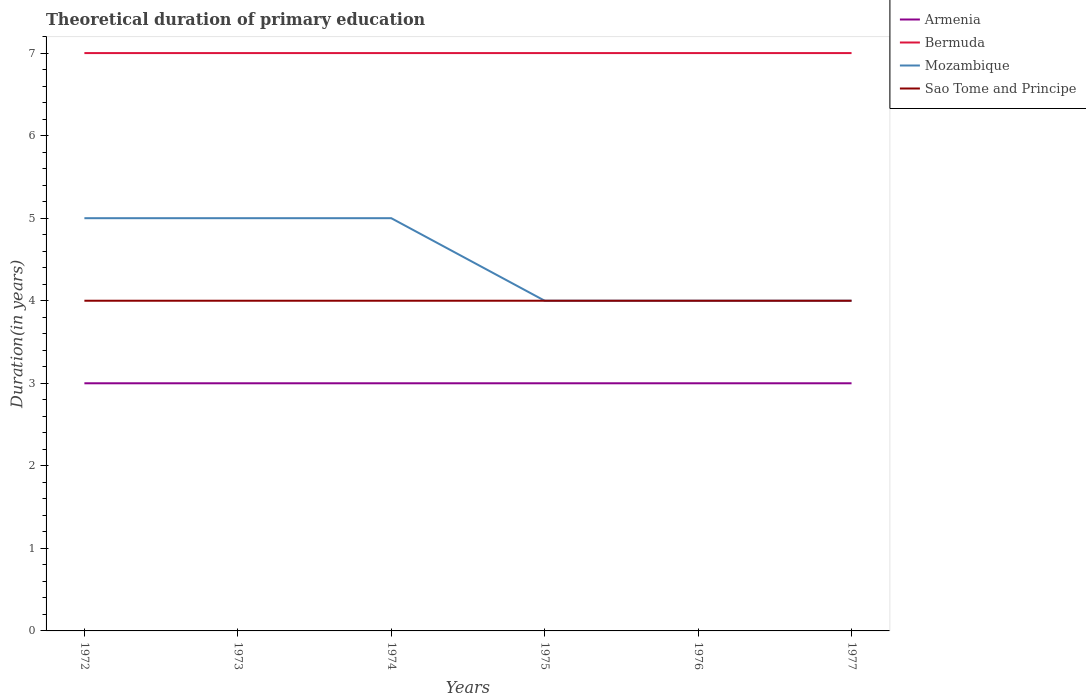Across all years, what is the maximum total theoretical duration of primary education in Sao Tome and Principe?
Your answer should be compact. 4. In which year was the total theoretical duration of primary education in Bermuda maximum?
Your answer should be compact. 1972. What is the difference between the highest and the second highest total theoretical duration of primary education in Bermuda?
Give a very brief answer. 0. What is the difference between the highest and the lowest total theoretical duration of primary education in Armenia?
Offer a terse response. 0. How many lines are there?
Offer a terse response. 4. How many years are there in the graph?
Provide a short and direct response. 6. Are the values on the major ticks of Y-axis written in scientific E-notation?
Ensure brevity in your answer.  No. Does the graph contain grids?
Provide a succinct answer. No. Where does the legend appear in the graph?
Make the answer very short. Top right. What is the title of the graph?
Offer a very short reply. Theoretical duration of primary education. Does "Uzbekistan" appear as one of the legend labels in the graph?
Your answer should be very brief. No. What is the label or title of the X-axis?
Offer a very short reply. Years. What is the label or title of the Y-axis?
Ensure brevity in your answer.  Duration(in years). What is the Duration(in years) in Sao Tome and Principe in 1972?
Your answer should be very brief. 4. What is the Duration(in years) of Mozambique in 1974?
Keep it short and to the point. 5. What is the Duration(in years) in Sao Tome and Principe in 1974?
Your answer should be compact. 4. What is the Duration(in years) of Armenia in 1975?
Give a very brief answer. 3. What is the Duration(in years) in Mozambique in 1975?
Offer a very short reply. 4. What is the Duration(in years) of Sao Tome and Principe in 1975?
Keep it short and to the point. 4. What is the Duration(in years) in Armenia in 1976?
Ensure brevity in your answer.  3. What is the Duration(in years) of Bermuda in 1976?
Offer a terse response. 7. What is the Duration(in years) of Mozambique in 1976?
Make the answer very short. 4. What is the Duration(in years) of Sao Tome and Principe in 1976?
Make the answer very short. 4. What is the Duration(in years) in Bermuda in 1977?
Your answer should be very brief. 7. What is the Duration(in years) in Mozambique in 1977?
Ensure brevity in your answer.  4. What is the Duration(in years) of Sao Tome and Principe in 1977?
Your response must be concise. 4. Across all years, what is the maximum Duration(in years) in Bermuda?
Offer a terse response. 7. Across all years, what is the maximum Duration(in years) of Mozambique?
Provide a succinct answer. 5. Across all years, what is the minimum Duration(in years) in Bermuda?
Provide a short and direct response. 7. What is the total Duration(in years) in Mozambique in the graph?
Provide a succinct answer. 27. What is the total Duration(in years) in Sao Tome and Principe in the graph?
Offer a terse response. 24. What is the difference between the Duration(in years) of Armenia in 1972 and that in 1973?
Your answer should be compact. 0. What is the difference between the Duration(in years) in Bermuda in 1972 and that in 1973?
Make the answer very short. 0. What is the difference between the Duration(in years) of Bermuda in 1972 and that in 1974?
Your answer should be very brief. 0. What is the difference between the Duration(in years) in Mozambique in 1972 and that in 1974?
Give a very brief answer. 0. What is the difference between the Duration(in years) in Sao Tome and Principe in 1972 and that in 1974?
Give a very brief answer. 0. What is the difference between the Duration(in years) of Armenia in 1972 and that in 1976?
Give a very brief answer. 0. What is the difference between the Duration(in years) of Bermuda in 1972 and that in 1976?
Offer a terse response. 0. What is the difference between the Duration(in years) of Sao Tome and Principe in 1972 and that in 1976?
Provide a succinct answer. 0. What is the difference between the Duration(in years) of Bermuda in 1972 and that in 1977?
Provide a succinct answer. 0. What is the difference between the Duration(in years) in Sao Tome and Principe in 1972 and that in 1977?
Keep it short and to the point. 0. What is the difference between the Duration(in years) of Bermuda in 1973 and that in 1974?
Ensure brevity in your answer.  0. What is the difference between the Duration(in years) in Mozambique in 1973 and that in 1974?
Offer a terse response. 0. What is the difference between the Duration(in years) in Sao Tome and Principe in 1973 and that in 1974?
Your response must be concise. 0. What is the difference between the Duration(in years) in Bermuda in 1973 and that in 1976?
Ensure brevity in your answer.  0. What is the difference between the Duration(in years) of Bermuda in 1973 and that in 1977?
Your response must be concise. 0. What is the difference between the Duration(in years) of Sao Tome and Principe in 1973 and that in 1977?
Keep it short and to the point. 0. What is the difference between the Duration(in years) of Armenia in 1974 and that in 1975?
Provide a short and direct response. 0. What is the difference between the Duration(in years) in Bermuda in 1974 and that in 1975?
Make the answer very short. 0. What is the difference between the Duration(in years) of Armenia in 1974 and that in 1976?
Offer a terse response. 0. What is the difference between the Duration(in years) in Bermuda in 1974 and that in 1976?
Make the answer very short. 0. What is the difference between the Duration(in years) of Mozambique in 1974 and that in 1976?
Keep it short and to the point. 1. What is the difference between the Duration(in years) of Bermuda in 1974 and that in 1977?
Ensure brevity in your answer.  0. What is the difference between the Duration(in years) of Sao Tome and Principe in 1974 and that in 1977?
Your answer should be compact. 0. What is the difference between the Duration(in years) of Mozambique in 1975 and that in 1976?
Offer a very short reply. 0. What is the difference between the Duration(in years) in Sao Tome and Principe in 1975 and that in 1976?
Make the answer very short. 0. What is the difference between the Duration(in years) of Mozambique in 1975 and that in 1977?
Offer a terse response. 0. What is the difference between the Duration(in years) of Sao Tome and Principe in 1975 and that in 1977?
Keep it short and to the point. 0. What is the difference between the Duration(in years) of Bermuda in 1976 and that in 1977?
Offer a terse response. 0. What is the difference between the Duration(in years) of Mozambique in 1976 and that in 1977?
Your answer should be compact. 0. What is the difference between the Duration(in years) of Sao Tome and Principe in 1976 and that in 1977?
Your response must be concise. 0. What is the difference between the Duration(in years) in Armenia in 1972 and the Duration(in years) in Bermuda in 1973?
Keep it short and to the point. -4. What is the difference between the Duration(in years) in Armenia in 1972 and the Duration(in years) in Mozambique in 1973?
Your answer should be compact. -2. What is the difference between the Duration(in years) of Bermuda in 1972 and the Duration(in years) of Sao Tome and Principe in 1973?
Make the answer very short. 3. What is the difference between the Duration(in years) of Armenia in 1972 and the Duration(in years) of Mozambique in 1974?
Provide a succinct answer. -2. What is the difference between the Duration(in years) of Armenia in 1972 and the Duration(in years) of Bermuda in 1975?
Your answer should be very brief. -4. What is the difference between the Duration(in years) of Bermuda in 1972 and the Duration(in years) of Sao Tome and Principe in 1975?
Your answer should be compact. 3. What is the difference between the Duration(in years) in Mozambique in 1972 and the Duration(in years) in Sao Tome and Principe in 1975?
Your answer should be compact. 1. What is the difference between the Duration(in years) in Armenia in 1972 and the Duration(in years) in Mozambique in 1976?
Give a very brief answer. -1. What is the difference between the Duration(in years) of Bermuda in 1972 and the Duration(in years) of Mozambique in 1976?
Your answer should be compact. 3. What is the difference between the Duration(in years) in Armenia in 1972 and the Duration(in years) in Bermuda in 1977?
Offer a terse response. -4. What is the difference between the Duration(in years) of Armenia in 1972 and the Duration(in years) of Sao Tome and Principe in 1977?
Make the answer very short. -1. What is the difference between the Duration(in years) of Bermuda in 1972 and the Duration(in years) of Sao Tome and Principe in 1977?
Keep it short and to the point. 3. What is the difference between the Duration(in years) in Bermuda in 1973 and the Duration(in years) in Mozambique in 1974?
Keep it short and to the point. 2. What is the difference between the Duration(in years) of Bermuda in 1973 and the Duration(in years) of Sao Tome and Principe in 1974?
Your response must be concise. 3. What is the difference between the Duration(in years) of Mozambique in 1973 and the Duration(in years) of Sao Tome and Principe in 1974?
Your answer should be very brief. 1. What is the difference between the Duration(in years) in Armenia in 1973 and the Duration(in years) in Mozambique in 1975?
Your response must be concise. -1. What is the difference between the Duration(in years) in Mozambique in 1973 and the Duration(in years) in Sao Tome and Principe in 1975?
Keep it short and to the point. 1. What is the difference between the Duration(in years) in Armenia in 1973 and the Duration(in years) in Bermuda in 1976?
Your answer should be very brief. -4. What is the difference between the Duration(in years) of Armenia in 1973 and the Duration(in years) of Sao Tome and Principe in 1976?
Give a very brief answer. -1. What is the difference between the Duration(in years) of Mozambique in 1973 and the Duration(in years) of Sao Tome and Principe in 1976?
Give a very brief answer. 1. What is the difference between the Duration(in years) of Armenia in 1973 and the Duration(in years) of Sao Tome and Principe in 1977?
Keep it short and to the point. -1. What is the difference between the Duration(in years) of Armenia in 1974 and the Duration(in years) of Bermuda in 1975?
Your answer should be compact. -4. What is the difference between the Duration(in years) of Armenia in 1974 and the Duration(in years) of Sao Tome and Principe in 1975?
Your answer should be very brief. -1. What is the difference between the Duration(in years) of Bermuda in 1974 and the Duration(in years) of Mozambique in 1975?
Offer a very short reply. 3. What is the difference between the Duration(in years) of Bermuda in 1974 and the Duration(in years) of Sao Tome and Principe in 1975?
Provide a succinct answer. 3. What is the difference between the Duration(in years) in Mozambique in 1974 and the Duration(in years) in Sao Tome and Principe in 1975?
Give a very brief answer. 1. What is the difference between the Duration(in years) of Armenia in 1974 and the Duration(in years) of Mozambique in 1976?
Your answer should be very brief. -1. What is the difference between the Duration(in years) in Armenia in 1974 and the Duration(in years) in Sao Tome and Principe in 1976?
Provide a short and direct response. -1. What is the difference between the Duration(in years) of Mozambique in 1974 and the Duration(in years) of Sao Tome and Principe in 1977?
Provide a short and direct response. 1. What is the difference between the Duration(in years) in Bermuda in 1975 and the Duration(in years) in Mozambique in 1976?
Ensure brevity in your answer.  3. What is the difference between the Duration(in years) in Armenia in 1975 and the Duration(in years) in Bermuda in 1977?
Ensure brevity in your answer.  -4. What is the difference between the Duration(in years) in Armenia in 1975 and the Duration(in years) in Mozambique in 1977?
Your answer should be compact. -1. What is the difference between the Duration(in years) in Armenia in 1975 and the Duration(in years) in Sao Tome and Principe in 1977?
Provide a short and direct response. -1. What is the difference between the Duration(in years) of Bermuda in 1975 and the Duration(in years) of Mozambique in 1977?
Ensure brevity in your answer.  3. What is the difference between the Duration(in years) of Bermuda in 1975 and the Duration(in years) of Sao Tome and Principe in 1977?
Ensure brevity in your answer.  3. What is the difference between the Duration(in years) of Mozambique in 1975 and the Duration(in years) of Sao Tome and Principe in 1977?
Your answer should be very brief. 0. What is the difference between the Duration(in years) of Armenia in 1976 and the Duration(in years) of Mozambique in 1977?
Provide a succinct answer. -1. What is the difference between the Duration(in years) in Bermuda in 1976 and the Duration(in years) in Sao Tome and Principe in 1977?
Provide a succinct answer. 3. What is the difference between the Duration(in years) in Mozambique in 1976 and the Duration(in years) in Sao Tome and Principe in 1977?
Keep it short and to the point. 0. What is the average Duration(in years) of Armenia per year?
Give a very brief answer. 3. What is the average Duration(in years) in Bermuda per year?
Make the answer very short. 7. In the year 1972, what is the difference between the Duration(in years) of Bermuda and Duration(in years) of Mozambique?
Your answer should be compact. 2. In the year 1972, what is the difference between the Duration(in years) in Bermuda and Duration(in years) in Sao Tome and Principe?
Offer a very short reply. 3. In the year 1973, what is the difference between the Duration(in years) in Armenia and Duration(in years) in Bermuda?
Provide a succinct answer. -4. In the year 1973, what is the difference between the Duration(in years) of Armenia and Duration(in years) of Mozambique?
Your answer should be very brief. -2. In the year 1973, what is the difference between the Duration(in years) of Armenia and Duration(in years) of Sao Tome and Principe?
Your answer should be very brief. -1. In the year 1973, what is the difference between the Duration(in years) in Bermuda and Duration(in years) in Mozambique?
Keep it short and to the point. 2. In the year 1973, what is the difference between the Duration(in years) in Mozambique and Duration(in years) in Sao Tome and Principe?
Provide a short and direct response. 1. In the year 1974, what is the difference between the Duration(in years) in Armenia and Duration(in years) in Bermuda?
Offer a terse response. -4. In the year 1974, what is the difference between the Duration(in years) in Armenia and Duration(in years) in Mozambique?
Your answer should be very brief. -2. In the year 1974, what is the difference between the Duration(in years) of Bermuda and Duration(in years) of Mozambique?
Your response must be concise. 2. In the year 1975, what is the difference between the Duration(in years) of Armenia and Duration(in years) of Bermuda?
Make the answer very short. -4. In the year 1975, what is the difference between the Duration(in years) of Armenia and Duration(in years) of Mozambique?
Ensure brevity in your answer.  -1. In the year 1975, what is the difference between the Duration(in years) in Bermuda and Duration(in years) in Mozambique?
Offer a terse response. 3. In the year 1975, what is the difference between the Duration(in years) of Bermuda and Duration(in years) of Sao Tome and Principe?
Make the answer very short. 3. In the year 1976, what is the difference between the Duration(in years) in Armenia and Duration(in years) in Mozambique?
Your answer should be compact. -1. In the year 1976, what is the difference between the Duration(in years) in Bermuda and Duration(in years) in Sao Tome and Principe?
Provide a succinct answer. 3. In the year 1977, what is the difference between the Duration(in years) in Mozambique and Duration(in years) in Sao Tome and Principe?
Your response must be concise. 0. What is the ratio of the Duration(in years) of Mozambique in 1972 to that in 1973?
Your response must be concise. 1. What is the ratio of the Duration(in years) in Armenia in 1972 to that in 1974?
Your answer should be very brief. 1. What is the ratio of the Duration(in years) of Bermuda in 1972 to that in 1974?
Your answer should be compact. 1. What is the ratio of the Duration(in years) of Mozambique in 1972 to that in 1974?
Make the answer very short. 1. What is the ratio of the Duration(in years) in Mozambique in 1972 to that in 1975?
Keep it short and to the point. 1.25. What is the ratio of the Duration(in years) of Armenia in 1972 to that in 1976?
Your answer should be very brief. 1. What is the ratio of the Duration(in years) in Bermuda in 1972 to that in 1976?
Give a very brief answer. 1. What is the ratio of the Duration(in years) in Mozambique in 1972 to that in 1976?
Your response must be concise. 1.25. What is the ratio of the Duration(in years) in Armenia in 1972 to that in 1977?
Provide a succinct answer. 1. What is the ratio of the Duration(in years) in Bermuda in 1973 to that in 1974?
Offer a terse response. 1. What is the ratio of the Duration(in years) of Mozambique in 1973 to that in 1975?
Ensure brevity in your answer.  1.25. What is the ratio of the Duration(in years) of Mozambique in 1973 to that in 1976?
Your answer should be very brief. 1.25. What is the ratio of the Duration(in years) in Armenia in 1973 to that in 1977?
Offer a terse response. 1. What is the ratio of the Duration(in years) in Bermuda in 1973 to that in 1977?
Keep it short and to the point. 1. What is the ratio of the Duration(in years) in Mozambique in 1973 to that in 1977?
Provide a short and direct response. 1.25. What is the ratio of the Duration(in years) of Sao Tome and Principe in 1973 to that in 1977?
Your response must be concise. 1. What is the ratio of the Duration(in years) of Bermuda in 1974 to that in 1975?
Ensure brevity in your answer.  1. What is the ratio of the Duration(in years) in Mozambique in 1974 to that in 1975?
Offer a terse response. 1.25. What is the ratio of the Duration(in years) of Armenia in 1974 to that in 1976?
Provide a short and direct response. 1. What is the ratio of the Duration(in years) of Bermuda in 1974 to that in 1976?
Offer a very short reply. 1. What is the ratio of the Duration(in years) in Mozambique in 1974 to that in 1976?
Give a very brief answer. 1.25. What is the ratio of the Duration(in years) of Sao Tome and Principe in 1974 to that in 1976?
Provide a succinct answer. 1. What is the ratio of the Duration(in years) of Mozambique in 1974 to that in 1977?
Keep it short and to the point. 1.25. What is the ratio of the Duration(in years) of Sao Tome and Principe in 1974 to that in 1977?
Offer a terse response. 1. What is the ratio of the Duration(in years) in Bermuda in 1975 to that in 1976?
Keep it short and to the point. 1. What is the ratio of the Duration(in years) of Bermuda in 1975 to that in 1977?
Offer a very short reply. 1. What is the ratio of the Duration(in years) in Mozambique in 1975 to that in 1977?
Your response must be concise. 1. What is the ratio of the Duration(in years) in Sao Tome and Principe in 1975 to that in 1977?
Keep it short and to the point. 1. What is the ratio of the Duration(in years) of Armenia in 1976 to that in 1977?
Make the answer very short. 1. What is the difference between the highest and the second highest Duration(in years) in Bermuda?
Provide a succinct answer. 0. What is the difference between the highest and the second highest Duration(in years) of Sao Tome and Principe?
Ensure brevity in your answer.  0. What is the difference between the highest and the lowest Duration(in years) of Bermuda?
Keep it short and to the point. 0. What is the difference between the highest and the lowest Duration(in years) in Sao Tome and Principe?
Make the answer very short. 0. 